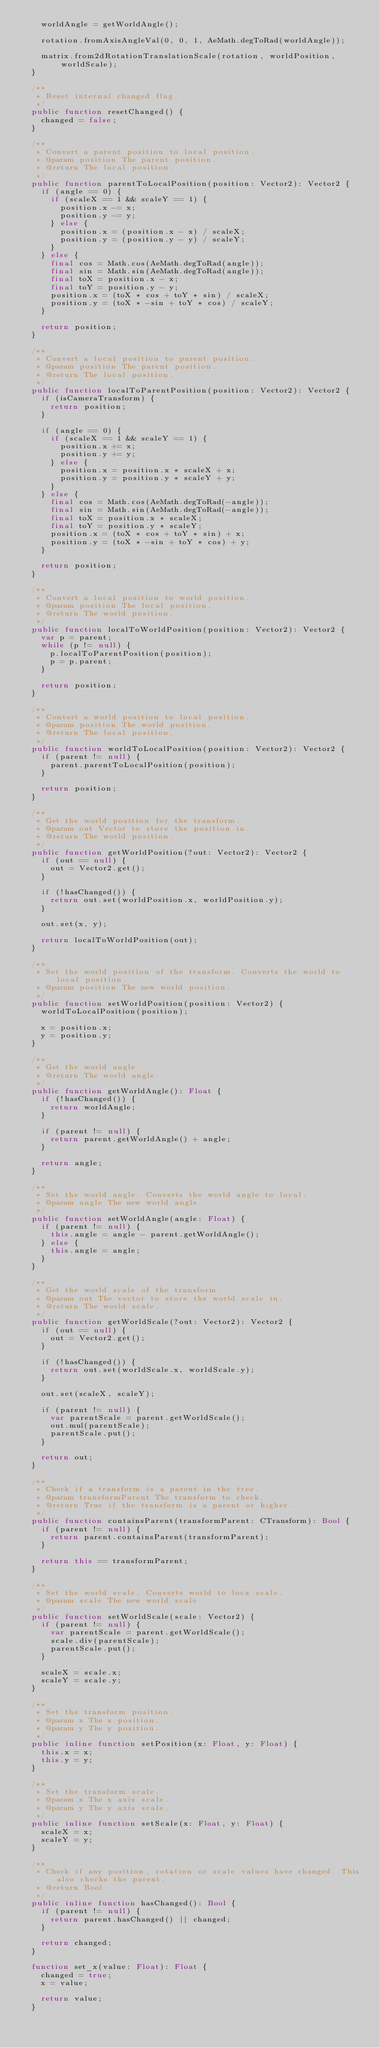<code> <loc_0><loc_0><loc_500><loc_500><_Haxe_>    worldAngle = getWorldAngle();

    rotation.fromAxisAngleVal(0, 0, 1, AeMath.degToRad(worldAngle));

    matrix.from2dRotationTranslationScale(rotation, worldPosition, worldScale);
  }

  /**
   * Reset internal changed flag.
   */
  public function resetChanged() {
    changed = false;
  }

  /**
   * Convert a parent position to local position.
   * @param position The parent position.
   * @return The local position.
   */
  public function parentToLocalPosition(position: Vector2): Vector2 {
    if (angle == 0) {
      if (scaleX == 1 && scaleY == 1) {
        position.x -= x;
        position.y -= y;
      } else {
        position.x = (position.x - x) / scaleX;
        position.y = (position.y - y) / scaleY;
      }
    } else {
      final cos = Math.cos(AeMath.degToRad(angle));
      final sin = Math.sin(AeMath.degToRad(angle));
      final toX = position.x - x;
      final toY = position.y - y;
      position.x = (toX * cos + toY * sin) / scaleX;
      position.y = (toX * -sin + toY * cos) / scaleY;
    }

    return position;
  }

  /**
   * Convert a local position to parent position.
   * @param position The parent position.
   * @return The local position.
   */
  public function localToParentPosition(position: Vector2): Vector2 {
    if (isCameraTransform) {
      return position;
    }

    if (angle == 0) {
      if (scaleX == 1 && scaleY == 1) {
        position.x += x;
        position.y += y;
      } else {
        position.x = position.x * scaleX + x;
        position.y = position.y * scaleY + y;
      }
    } else {
      final cos = Math.cos(AeMath.degToRad(-angle));
      final sin = Math.sin(AeMath.degToRad(-angle));
      final toX = position.x * scaleX;
      final toY = position.y * scaleY;
      position.x = (toX * cos + toY * sin) + x;
      position.y = (toX * -sin + toY * cos) + y;
    }

    return position;
  }

  /**
   * Convert a local position to world position.
   * @param position The local position.
   * @return The world position.
   */
  public function localToWorldPosition(position: Vector2): Vector2 {
    var p = parent;
    while (p != null) {
      p.localToParentPosition(position);
      p = p.parent;
    }

    return position;
  }

  /**
   * Convert a world position to local position.
   * @param position The world position.
   * @return The local position.
   */
  public function worldToLocalPosition(position: Vector2): Vector2 {
    if (parent != null) {
      parent.parentToLocalPosition(position);
    }

    return position;
  }

  /**
   * Get the world position for the transform.
   * @param out Vector to store the position in.
   * @return The world position.
   */
  public function getWorldPosition(?out: Vector2): Vector2 {
    if (out == null) {
      out = Vector2.get();
    }

    if (!hasChanged()) {
      return out.set(worldPosition.x, worldPosition.y);
    }

    out.set(x, y);

    return localToWorldPosition(out);
  }

  /**
   * Set the world position of the transform. Converts the world to local position.
   * @param position The new world position.
   */
  public function setWorldPosition(position: Vector2) {
    worldToLocalPosition(position);

    x = position.x;
    y = position.y;
  }

  /**
   * Get the world angle.
   * @return The world angle.
   */
  public function getWorldAngle(): Float {
    if (!hasChanged()) {
      return worldAngle;
    }

    if (parent != null) {
      return parent.getWorldAngle() + angle;
    }

    return angle;
  }

  /**
   * Set the world angle. Converts the world angle to local.
   * @param angle The new world angle.
   */
  public function setWorldAngle(angle: Float) {
    if (parent != null) {
      this.angle = angle - parent.getWorldAngle();
    } else {
      this.angle = angle;
    }
  }

  /**
   * Get the world scale of the transform.
   * @param out The vector to store the world scale in.
   * @return The world scale.
   */
  public function getWorldScale(?out: Vector2): Vector2 {
    if (out == null) {
      out = Vector2.get();
    }

    if (!hasChanged()) {
      return out.set(worldScale.x, worldScale.y);
    }

    out.set(scaleX, scaleY);

    if (parent != null) {
      var parentScale = parent.getWorldScale();
      out.mul(parentScale);
      parentScale.put();
    }

    return out;
  }

  /**
   * Check if a transform is a parent in the tree.
   * @param transformParent The transform to check.
   * @return True if the transform is a parent or higher.
   */
  public function containsParent(transformParent: CTransform): Bool {
    if (parent != null) {
      return parent.containsParent(transformParent);
    }

    return this == transformParent;
  }

  /**
   * Set the world scale. Converts world to loca scale.
   * @param scale The new world scale.
   */
  public function setWorldScale(scale: Vector2) {
    if (parent != null) {
      var parentScale = parent.getWorldScale();
      scale.div(parentScale);
      parentScale.put();
    }

    scaleX = scale.x;
    scaleY = scale.y;
  }

  /**
   * Set the transform position.
   * @param x The x position.
   * @param y The y position.
   */
  public inline function setPosition(x: Float, y: Float) {
    this.x = x;
    this.y = y;
  }

  /**
   * Set the transform scale.
   * @param x The x axis scale.
   * @param y The y axis scale.
   */
  public inline function setScale(x: Float, y: Float) {
    scaleX = x;
    scaleY = y;
  }

  /**
   * Check if any position, rotation or scale values have changed. This also checks the parent.
   * @return Bool
   */
  public inline function hasChanged(): Bool {
    if (parent != null) {
      return parent.hasChanged() || changed;
    }

    return changed;
  }

  function set_x(value: Float): Float {
    changed = true;
    x = value;

    return value;
  }
</code> 